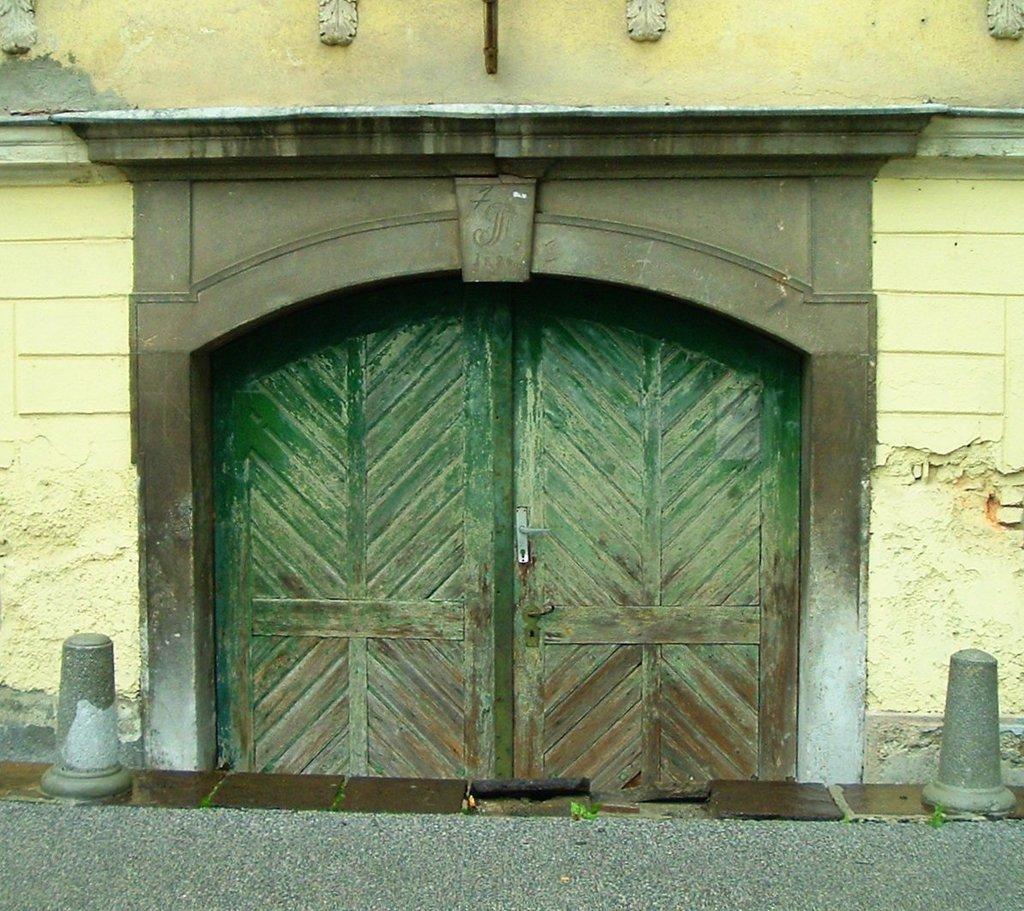Could you give a brief overview of what you see in this image? In this image I see the building and I see the doors over here and I see the path. 